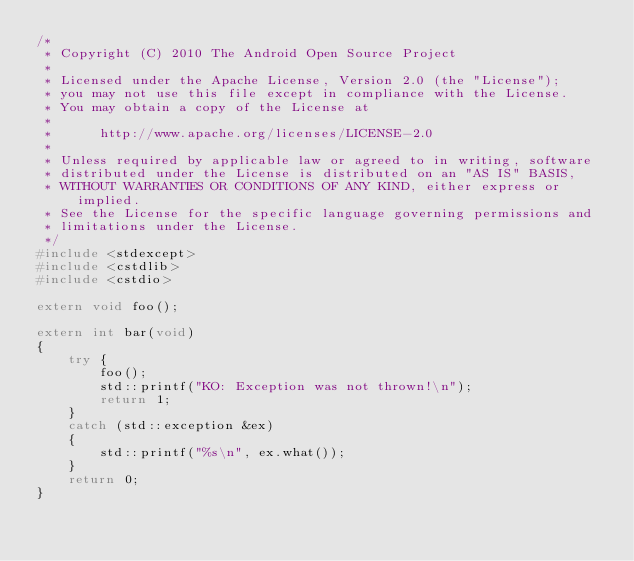<code> <loc_0><loc_0><loc_500><loc_500><_C++_>/*
 * Copyright (C) 2010 The Android Open Source Project
 *
 * Licensed under the Apache License, Version 2.0 (the "License");
 * you may not use this file except in compliance with the License.
 * You may obtain a copy of the License at
 *
 *      http://www.apache.org/licenses/LICENSE-2.0
 *
 * Unless required by applicable law or agreed to in writing, software
 * distributed under the License is distributed on an "AS IS" BASIS,
 * WITHOUT WARRANTIES OR CONDITIONS OF ANY KIND, either express or implied.
 * See the License for the specific language governing permissions and
 * limitations under the License.
 */
#include <stdexcept>
#include <cstdlib>
#include <cstdio>

extern void foo();

extern int bar(void)
{
    try {
        foo();
        std::printf("KO: Exception was not thrown!\n");
        return 1;
    }
    catch (std::exception &ex)
    {
        std::printf("%s\n", ex.what());
    }
    return 0;
}
</code> 